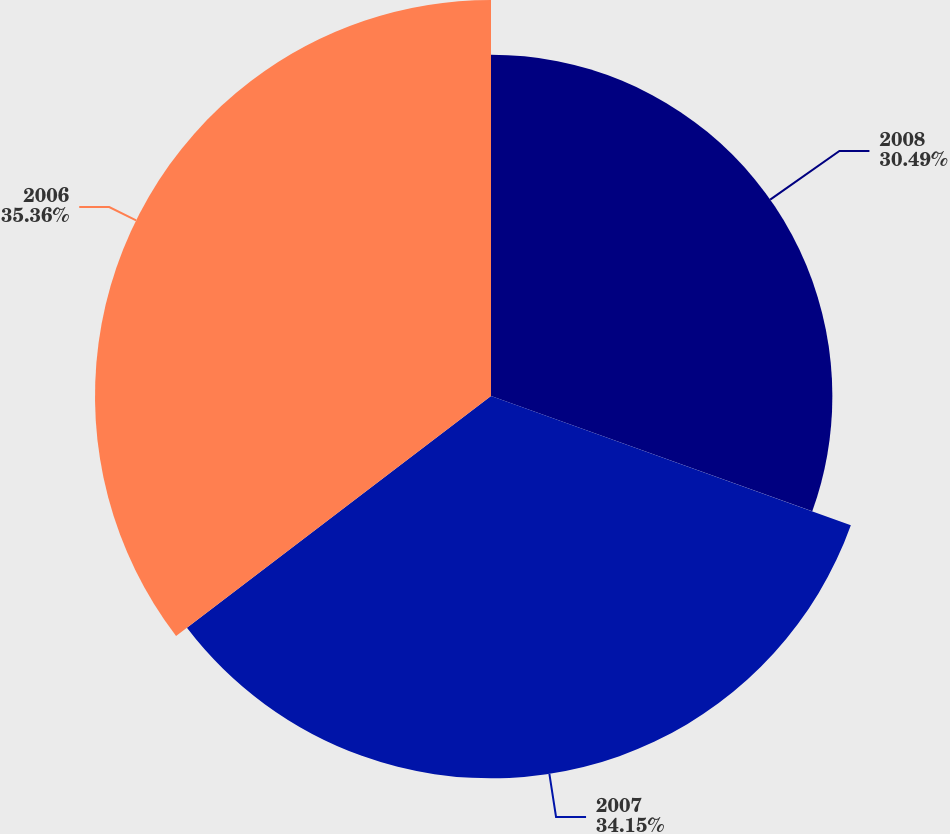Convert chart to OTSL. <chart><loc_0><loc_0><loc_500><loc_500><pie_chart><fcel>2008<fcel>2007<fcel>2006<nl><fcel>30.49%<fcel>34.15%<fcel>35.37%<nl></chart> 